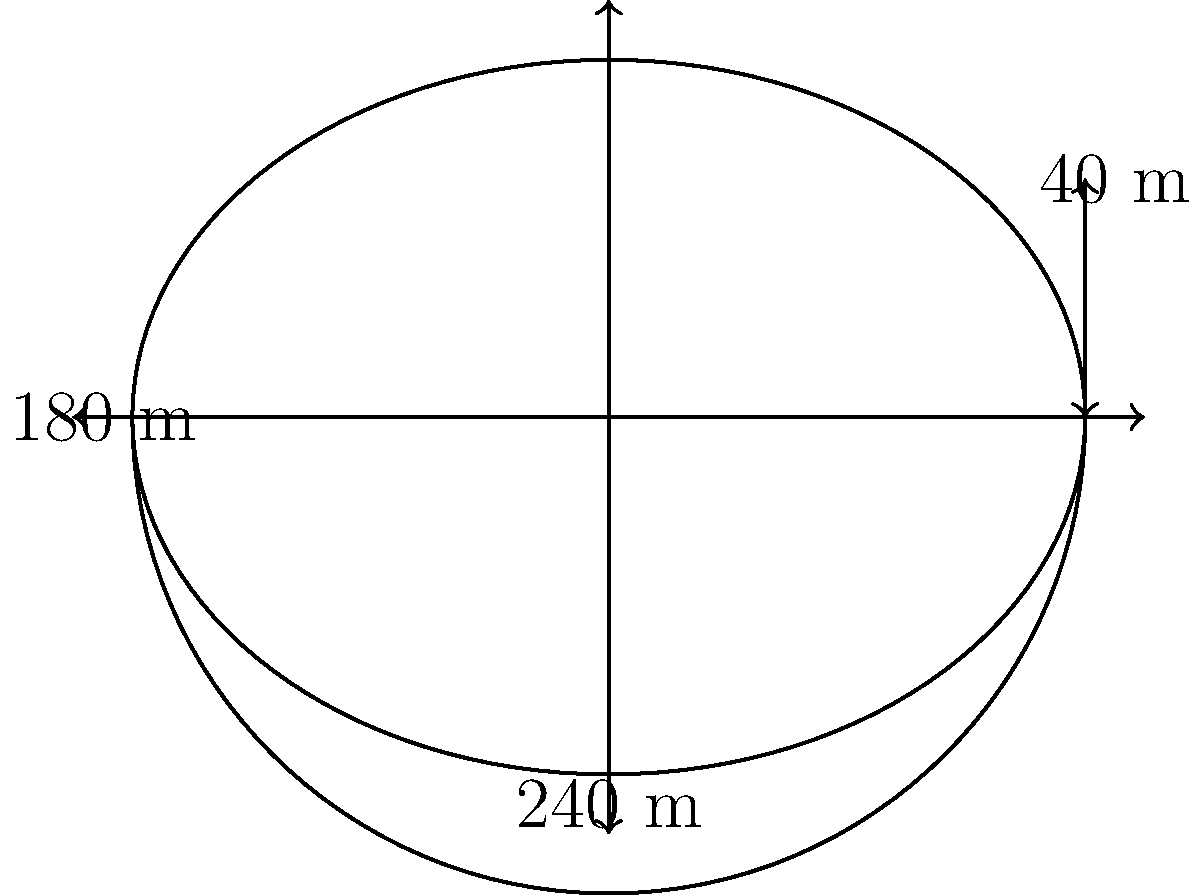As a savvy investor collaborating with a retired athlete on a new stadium project, you need to calculate the surface area of the proposed dome-shaped roof. The stadium has an elliptical base with a length of 240 m and a width of 180 m. The dome rises to a height of 40 m at its center. Assuming the dome is a perfect half-ellipsoid, what is the surface area of the roof in square meters? Round your answer to the nearest 100 m². To calculate the surface area of the dome-shaped roof, we'll use the formula for the surface area of a half-ellipsoid:

$$S = \pi ab \left(1 + \frac{c^2}{ab} \cdot \frac{\arcsin(e)}{e}\right)$$

Where:
$a$ = half-length of the stadium = 240/2 = 120 m
$b$ = half-width of the stadium = 180/2 = 90 m
$c$ = height of the dome = 40 m
$e$ = eccentricity = $\sqrt{1 - \frac{b^2}{a^2}}$

Step 1: Calculate the eccentricity (e)
$$e = \sqrt{1 - \frac{90^2}{120^2}} = \sqrt{1 - 0.5625} = 0.6614$$

Step 2: Calculate $\frac{\arcsin(e)}{e}$
$$\frac{\arcsin(0.6614)}{0.6614} = 1.1547$$

Step 3: Substitute all values into the surface area formula
$$S = \pi \cdot 120 \cdot 90 \left(1 + \frac{40^2}{120 \cdot 90} \cdot 1.1547\right)$$

Step 4: Simplify and calculate
$$S = 33,929.2 + 6,138.4 = 40,067.6 \text{ m}^2$$

Step 5: Round to the nearest 100 m²
$$S \approx 40,100 \text{ m}^2$$
Answer: 40,100 m² 